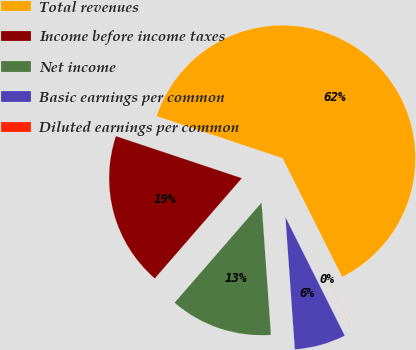Convert chart to OTSL. <chart><loc_0><loc_0><loc_500><loc_500><pie_chart><fcel>Total revenues<fcel>Income before income taxes<fcel>Net income<fcel>Basic earnings per common<fcel>Diluted earnings per common<nl><fcel>62.47%<fcel>18.75%<fcel>12.51%<fcel>6.26%<fcel>0.02%<nl></chart> 